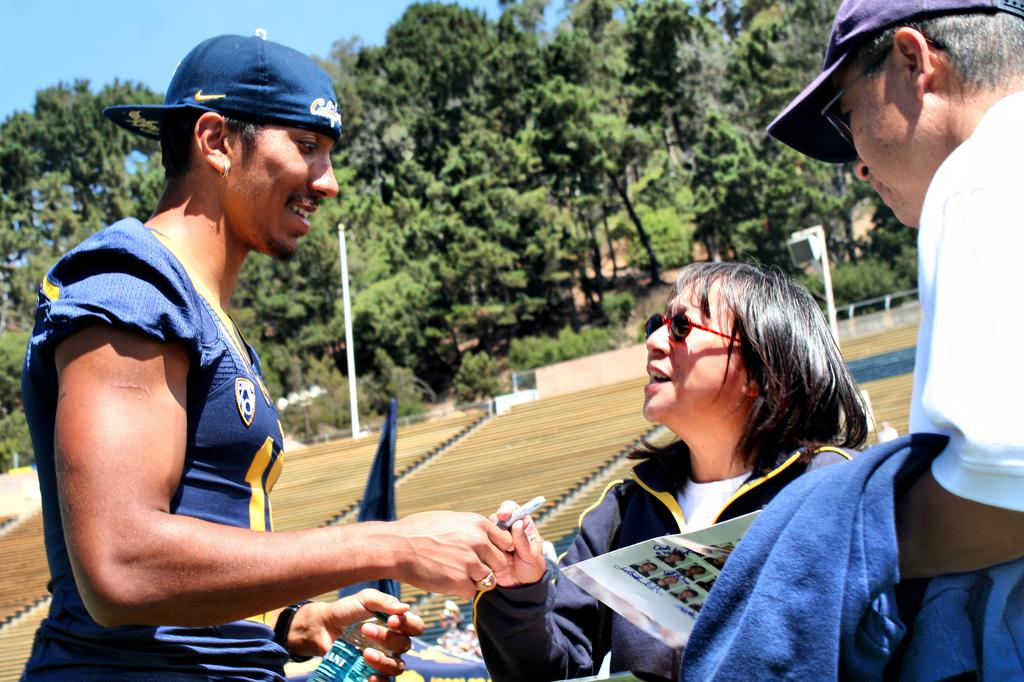How many people are in the image? There are three people in the image. What are some of the people wearing? Some of the people are wearing caps and goggles. What objects can be seen in the image? There is a pen, a bottle, and paper in the image. What type of clothing is visible in the image? There are clothes in the image. What can be seen in the background of the image? There are poles, fences, trees, and some unspecified objects in the background of the image. What is visible in the sky in the image? The sky is visible in the background of the image. What type of decision can be seen being made by the people in the image? There is no indication of a decision being made in the image. Can you see a knife on the floor in the image? There is no knife or floor present in the image. 